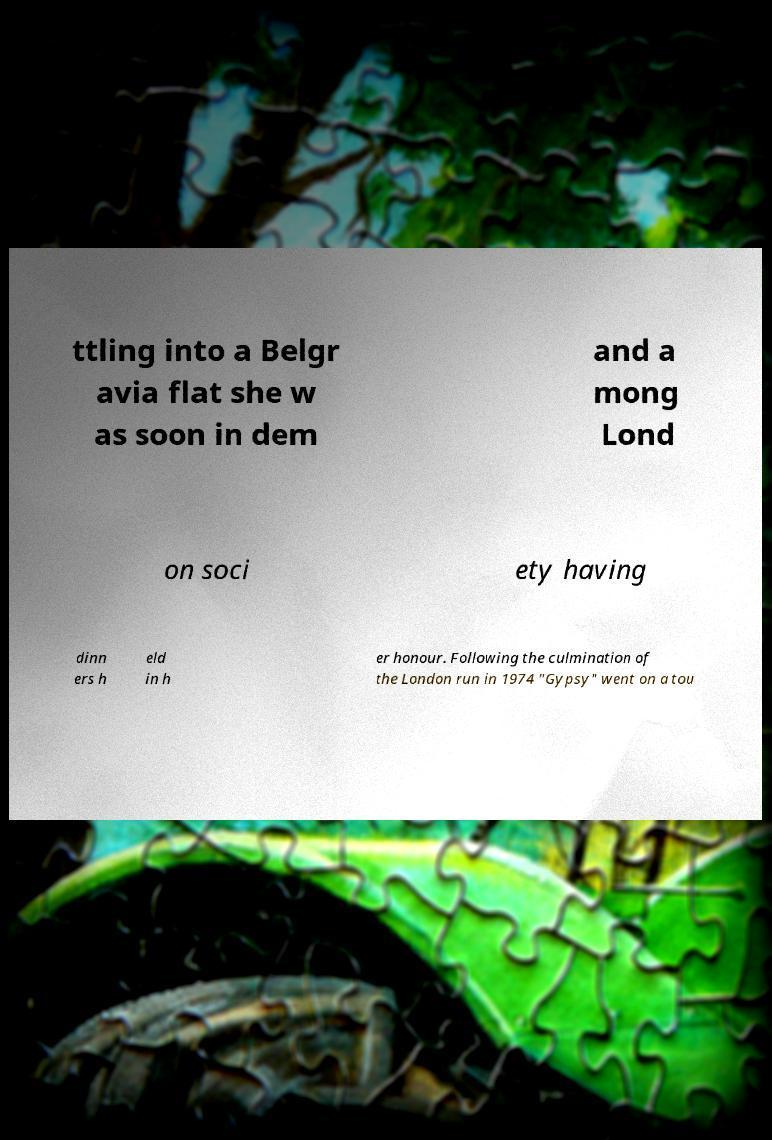I need the written content from this picture converted into text. Can you do that? ttling into a Belgr avia flat she w as soon in dem and a mong Lond on soci ety having dinn ers h eld in h er honour. Following the culmination of the London run in 1974 "Gypsy" went on a tou 